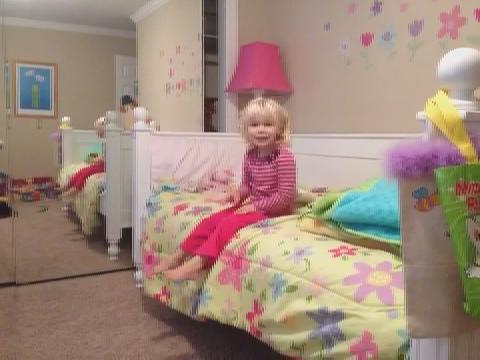What type of finish or item covers the back wall? Please explain your reasoning. mirror. A girl sitting on a bed is reflected on the wall behind her. 